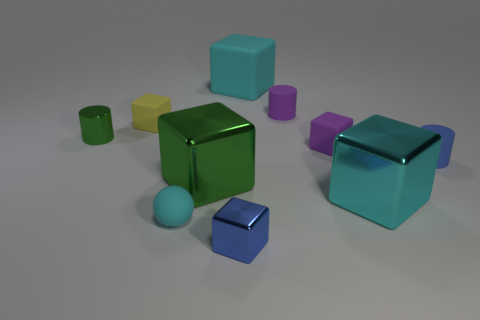Is the color of the tiny ball the same as the big matte object?
Your answer should be very brief. Yes. How many objects are either cyan shiny cubes or large brown balls?
Your answer should be very brief. 1. Are any tiny cyan cylinders visible?
Your answer should be compact. No. What material is the small cube that is on the left side of the blue object that is on the left side of the blue thing on the right side of the big cyan matte thing made of?
Keep it short and to the point. Rubber. Are there fewer blue matte cylinders that are in front of the tiny metallic block than tiny blue matte spheres?
Your answer should be very brief. No. There is a blue cylinder that is the same size as the purple matte cylinder; what is its material?
Offer a terse response. Rubber. There is a shiny block that is behind the blue metal block and right of the large green metallic object; what size is it?
Provide a short and direct response. Large. There is a blue thing that is the same shape as the large green metal object; what size is it?
Ensure brevity in your answer.  Small. What number of things are small purple matte cubes or green objects right of the tiny cyan object?
Provide a succinct answer. 2. There is a blue matte object; what shape is it?
Keep it short and to the point. Cylinder. 